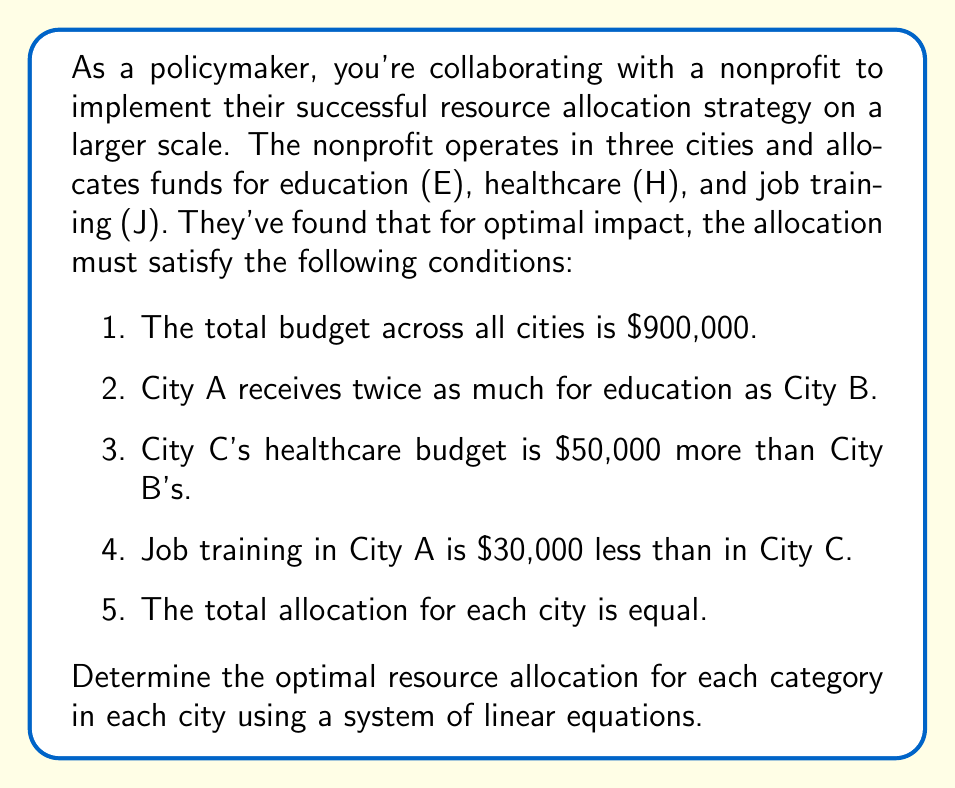Help me with this question. Let's approach this step-by-step using variables for each allocation:

1. Define variables:
   $E_A, H_A, J_A$ for City A's education, healthcare, and job training
   $E_B, H_B, J_B$ for City B
   $E_C, H_C, J_C$ for City C

2. Set up equations based on the given conditions:

   Total budget: 
   $$(E_A + H_A + J_A) + (E_B + H_B + J_B) + (E_C + H_C + J_C) = 900,000$$

   City A's education vs City B:
   $$E_A = 2E_B$$

   City C's healthcare vs City B:
   $$H_C = H_B + 50,000$$

   City A's job training vs City C:
   $$J_A = J_C - 30,000$$

   Equal allocation for each city:
   $$E_A + H_A + J_A = E_B + H_B + J_B = E_C + H_C + J_C$$

3. Simplify the system by expressing everything in terms of City B's allocations:

   $$(2E_B + H_B + J_C - 30,000) + (E_B + H_B + J_B) + (E_B + H_B + 50,000 + J_C) = 900,000$$

   $$4E_B + 3H_B + J_B + 2J_C = 880,000$$

   $$2E_B + H_B + J_C - 30,000 = E_B + H_B + J_B = E_B + H_B + 50,000 + J_C$$

4. From the last equation:
   $$E_B = J_B + 30,000 = 50,000 + J_C$$

   $$J_B = J_C + 20,000$$

5. Substitute these into the total budget equation:

   $$4(J_C + 80,000) + 3H_B + (J_C + 20,000) + 2J_C = 880,000$$
   $$7J_C + 3H_B = 560,000$$

6. From the equal allocation condition:

   $$3(J_C + 80,000) + 3H_B = 900,000 / 3 = 300,000$$
   $$3J_C + 3H_B = 60,000$$

7. Solve these two equations:

   $$7J_C + 3H_B = 560,000$$
   $$3J_C + 3H_B = 60,000$$
   
   Subtracting the second from the first:
   $$4J_C = 500,000$$
   $$J_C = 125,000$$

   Substituting back:
   $$3H_B = 60,000 - 3(125,000) = -315,000$$
   $$H_B = -105,000$$

8. Now we can calculate all values:

   City C: $J_C = 125,000$, $H_C = -55,000$, $E_C = 230,000$
   City B: $J_B = 145,000$, $H_B = -105,000$, $E_B = 260,000$
   City A: $J_A = 95,000$, $H_A = -105,000$, $E_A = 310,000$

9. The negative values for healthcare are not realistic. We need to adjust our initial assumptions or constraints to find a feasible solution.
Answer: The system has no feasible solution with non-negative allocations. 